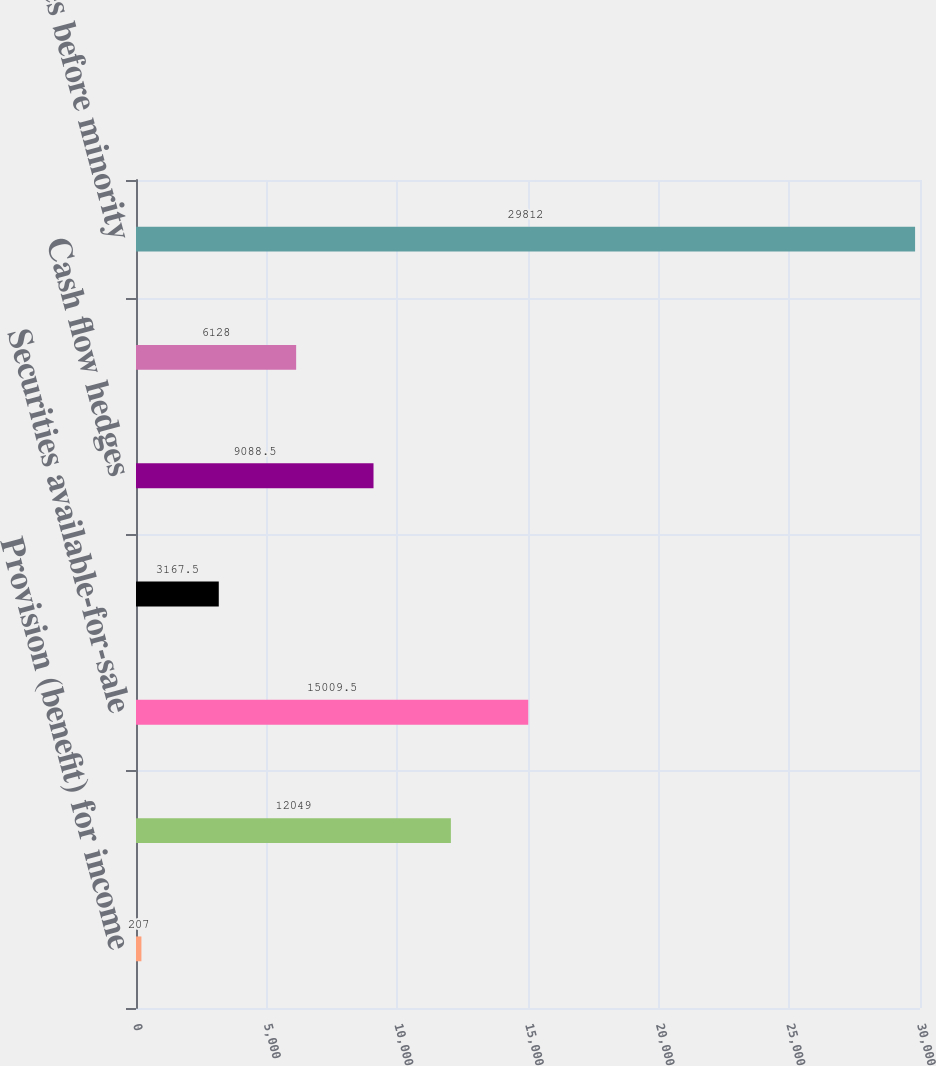Convert chart to OTSL. <chart><loc_0><loc_0><loc_500><loc_500><bar_chart><fcel>Provision (benefit) for income<fcel>Foreign currency translation<fcel>Securities available-for-sale<fcel>Employee stock plans<fcel>Cash flow hedges<fcel>Pension liability adjustments<fcel>Income taxes before minority<nl><fcel>207<fcel>12049<fcel>15009.5<fcel>3167.5<fcel>9088.5<fcel>6128<fcel>29812<nl></chart> 